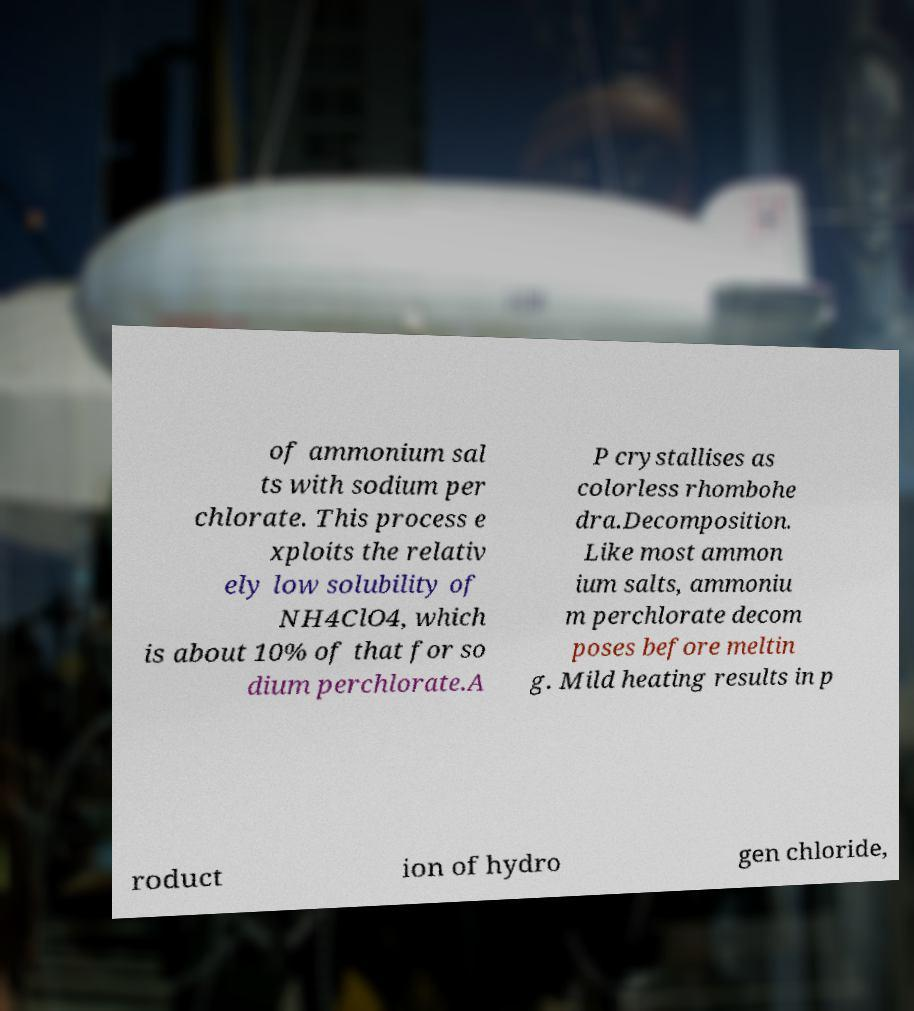For documentation purposes, I need the text within this image transcribed. Could you provide that? of ammonium sal ts with sodium per chlorate. This process e xploits the relativ ely low solubility of NH4ClO4, which is about 10% of that for so dium perchlorate.A P crystallises as colorless rhombohe dra.Decomposition. Like most ammon ium salts, ammoniu m perchlorate decom poses before meltin g. Mild heating results in p roduct ion of hydro gen chloride, 